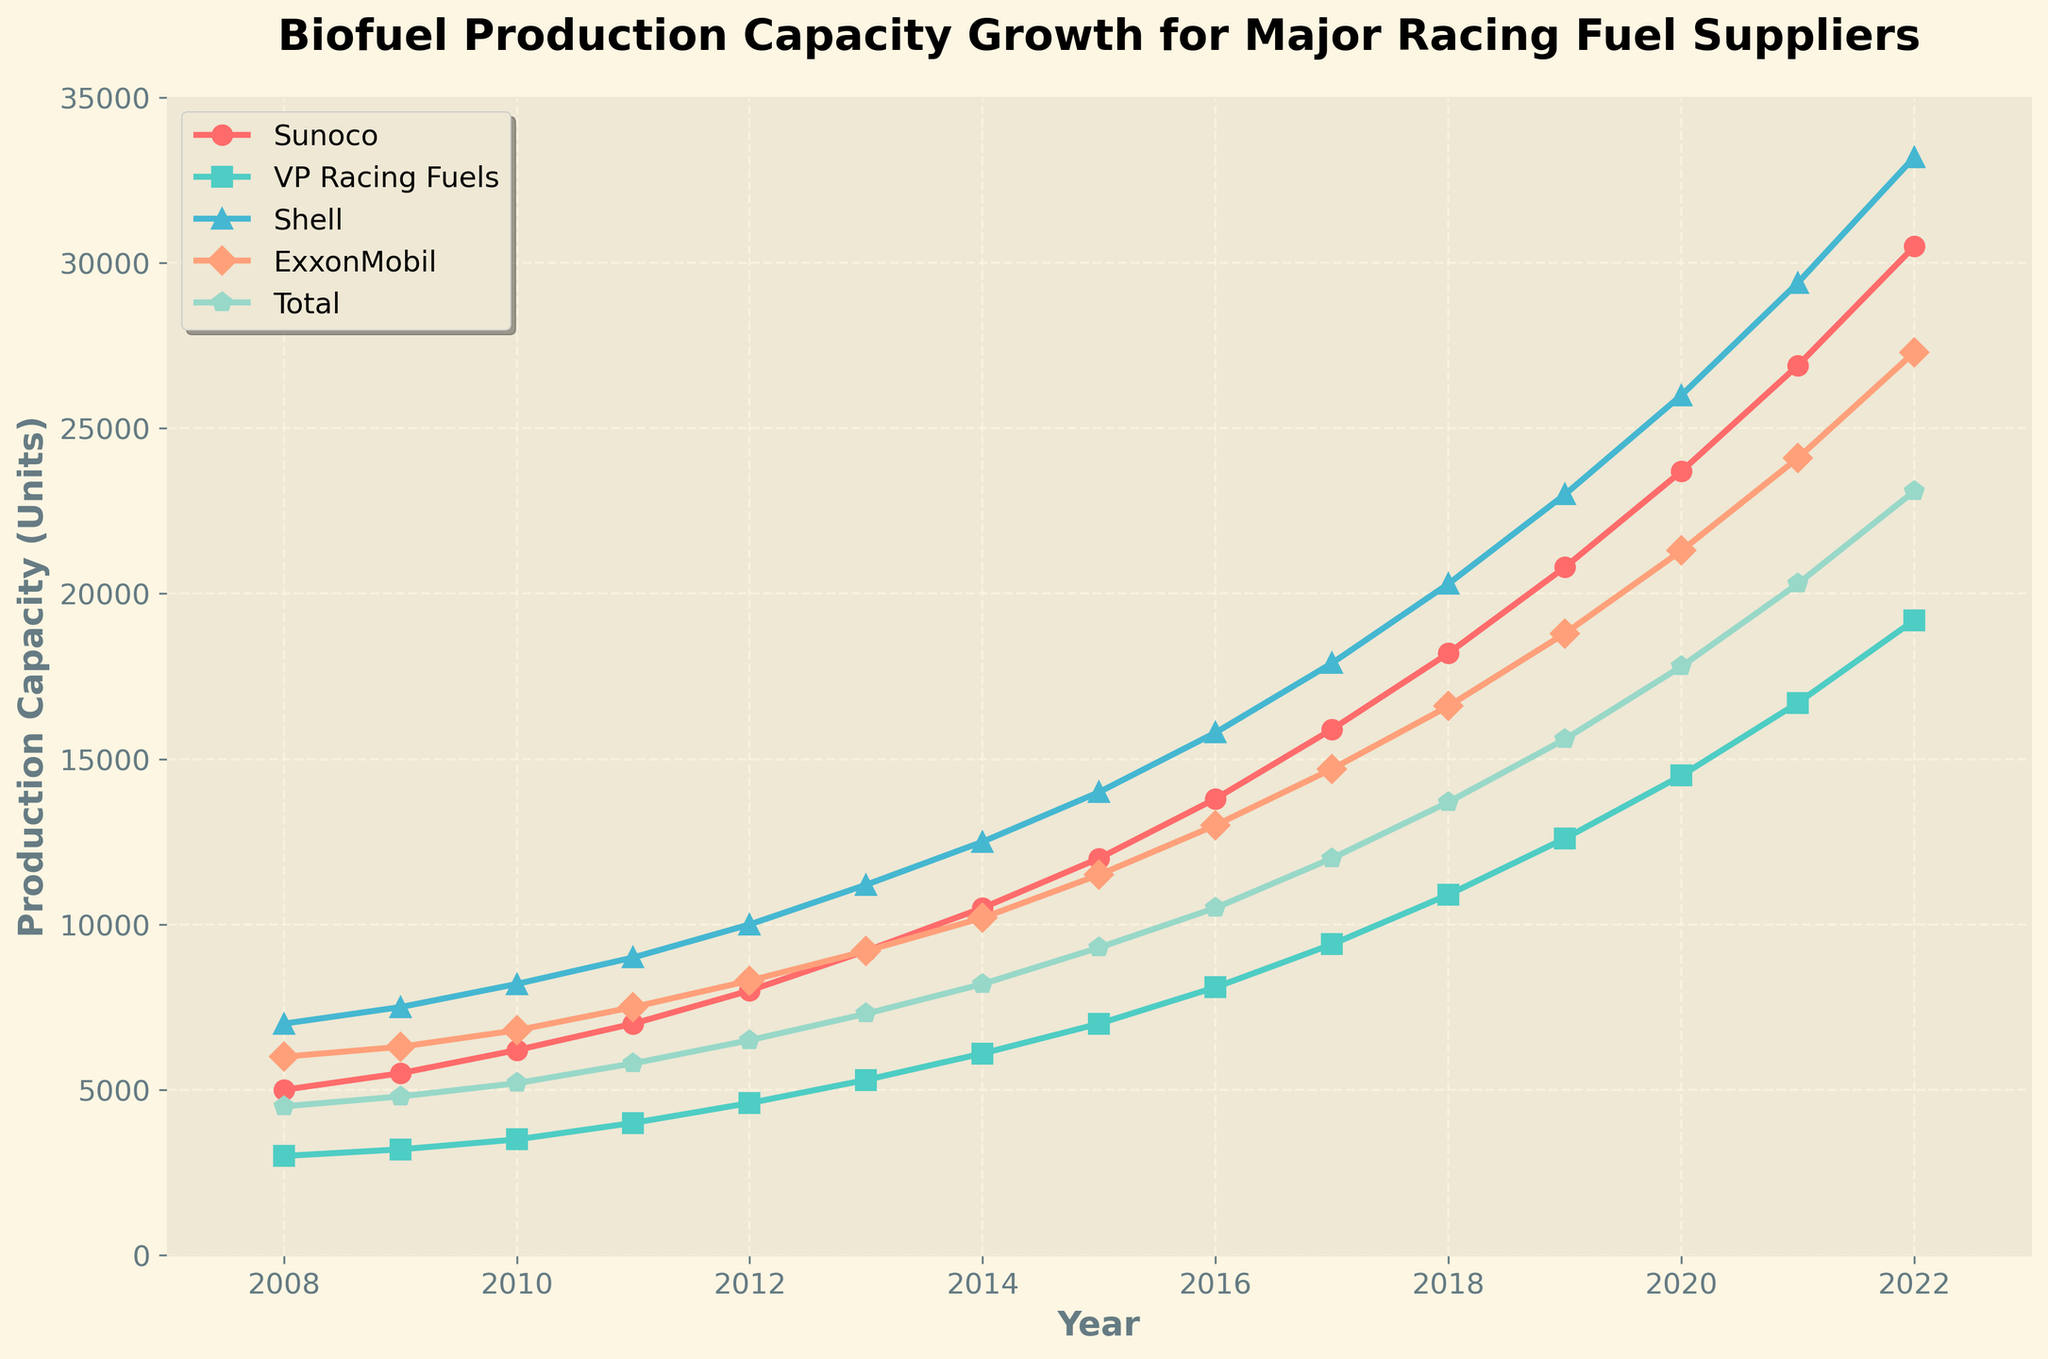What was the production capacity of VP Racing Fuels in 2015? The graph shows that the production capacity for VP Racing Fuels in 2015 is marked by the green square on the vertical scale. The value is 7000 units.
Answer: 7000 Which supplier had the highest production capacity in 2012? Look at the height of the lines in 2012. The line representing Shell (blue triangle) is the highest, indicating the highest production capacity.
Answer: Shell By how much did Sunoco's production capacity increase from 2010 to 2015? Sunoco's production capacity in 2010 was 6200 units, and in 2015 it was 12000 units. Subtract 6200 from 12000 to get the increase.
Answer: 5800 In which year did ExxonMobil surpass Total in production capacity? ExxonMobil (orange hexagon) line surpasses Total (purple pentagon) line between 2009 and 2010. Comparing the exact values, ExxonMobil surpassed Total in 2010.
Answer: 2010 What is the average production capacity of all suppliers in 2017? Sum the production capacities for all suppliers in 2017 (15900 + 9400 + 17900 + 14700 + 12000 = 69900) and divide by 5.
Answer: 13980 Which supplier had the smallest growth in production capacity from 2008 to 2022? Calculate the difference in production capacity for each supplier from 2008 to 2022. VP Racing Fuels (turquoise diamond) grew from 3000 to 19200, the least compared to others.
Answer: VP Racing Fuels Which year saw the highest increase in biofuel production capacity for Shell? Compare the year-over-year increase for Shell's production capacity. The highest jump occurred between 2021 and 2022, with an increase from 29400 to 33200 (3800 units).
Answer: 2022 What is the total production capacity of all suppliers in 2020? Sum the production capacities of all suppliers in 2020 (23700 + 14500 + 26000 + 21300 + 17800).
Answer: 103300 How does the production capacity of ExxonMobil in 2019 compare to that of VP Racing Fuels in 2022? Compare the values directly: ExxonMobil had 18800 units in 2019 and VP Racing Fuels had 19200 units in 2022.
Answer: VP Racing Fuels had more 